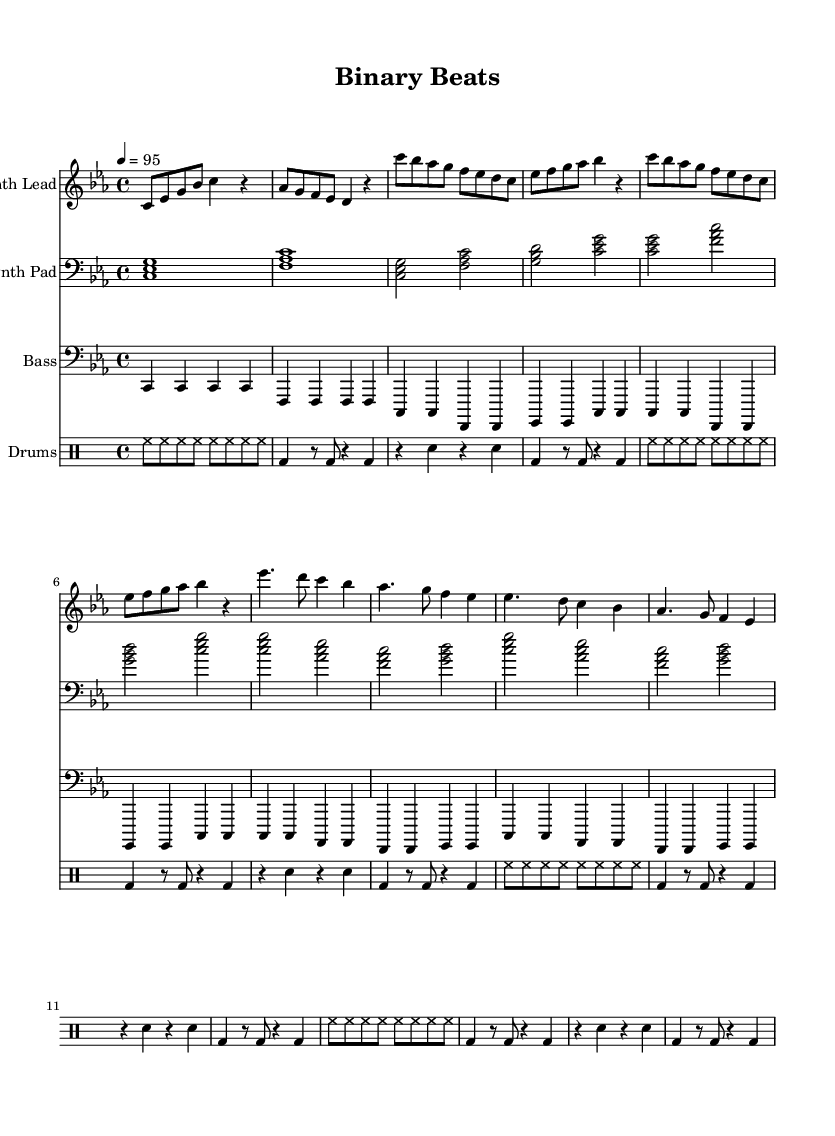What is the key signature of this music? The key signature is indicated at the beginning of the music. In this case, it is C minor, which is represented by three flats (B flat, E flat, and A flat).
Answer: C minor What is the time signature of the piece? The time signature is shown next to the key signature at the beginning of the music. Here, it is 4/4, meaning there are four beats in each measure and the quarter note gets one beat.
Answer: 4/4 What is the tempo marking of the music? The tempo is indicated in the score with a metronome marking. It shows that the piece should be played at a speed of 95 beats per minute.
Answer: 95 How many measures are in the verse section? The verse section consists of two repetitions of four bars each, totaling eight measures. This can be counted from the score.
Answer: 8 What type of instruments are featured in this piece? The instruments can be identified by the labels given for each staff in the score. The piece features a Synth Lead, Synth Pad, Bass, and Drums.
Answer: Synth Lead, Synth Pad, Bass, Drums What rhythmic pattern is used in the drum section? The drum section shows a consistent pattern repeated through the measures, including hi-hats and kicks. The hi-hat plays steadily while kick drums and snares are used to create a groove typically found in hip hop.
Answer: Hi-hat and kick What is the thematic focus of the lyrics suggested by the title? The title "Binary Beats" implies a focus on technology themes, particularly artificial intelligence and machine learning, which is typical in futuristic hip hop. This is inferred from both the title and the overall instrumentation.
Answer: Artificial intelligence and machine learning 